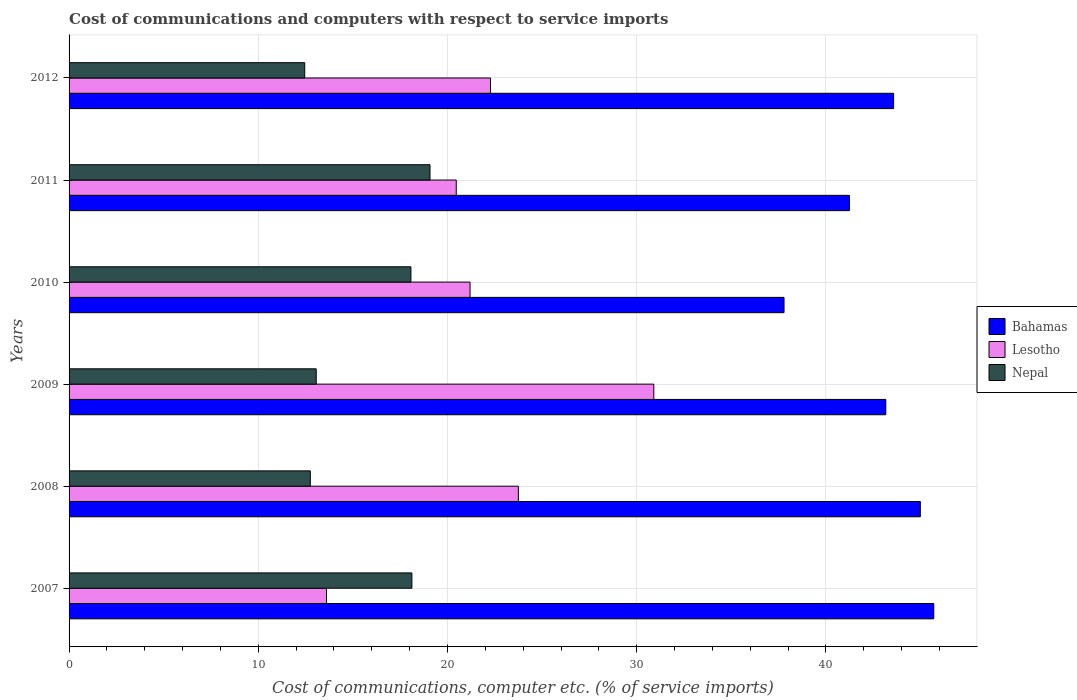How many different coloured bars are there?
Provide a short and direct response. 3. How many groups of bars are there?
Your answer should be very brief. 6. Are the number of bars on each tick of the Y-axis equal?
Your answer should be compact. Yes. How many bars are there on the 1st tick from the top?
Provide a short and direct response. 3. How many bars are there on the 4th tick from the bottom?
Offer a very short reply. 3. In how many cases, is the number of bars for a given year not equal to the number of legend labels?
Your response must be concise. 0. What is the cost of communications and computers in Nepal in 2010?
Your answer should be very brief. 18.07. Across all years, what is the maximum cost of communications and computers in Nepal?
Your answer should be very brief. 19.07. Across all years, what is the minimum cost of communications and computers in Nepal?
Provide a short and direct response. 12.45. In which year was the cost of communications and computers in Lesotho maximum?
Offer a very short reply. 2009. What is the total cost of communications and computers in Bahamas in the graph?
Provide a short and direct response. 256.45. What is the difference between the cost of communications and computers in Bahamas in 2009 and that in 2012?
Your answer should be compact. -0.41. What is the difference between the cost of communications and computers in Nepal in 2010 and the cost of communications and computers in Lesotho in 2009?
Offer a terse response. -12.84. What is the average cost of communications and computers in Bahamas per year?
Your answer should be very brief. 42.74. In the year 2010, what is the difference between the cost of communications and computers in Nepal and cost of communications and computers in Bahamas?
Your response must be concise. -19.72. In how many years, is the cost of communications and computers in Bahamas greater than 44 %?
Keep it short and to the point. 2. What is the ratio of the cost of communications and computers in Nepal in 2007 to that in 2012?
Make the answer very short. 1.45. Is the difference between the cost of communications and computers in Nepal in 2009 and 2012 greater than the difference between the cost of communications and computers in Bahamas in 2009 and 2012?
Provide a short and direct response. Yes. What is the difference between the highest and the second highest cost of communications and computers in Nepal?
Offer a terse response. 0.96. What is the difference between the highest and the lowest cost of communications and computers in Bahamas?
Your answer should be compact. 7.91. In how many years, is the cost of communications and computers in Nepal greater than the average cost of communications and computers in Nepal taken over all years?
Provide a succinct answer. 3. Is the sum of the cost of communications and computers in Nepal in 2008 and 2011 greater than the maximum cost of communications and computers in Bahamas across all years?
Offer a terse response. No. What does the 2nd bar from the top in 2008 represents?
Offer a terse response. Lesotho. What does the 2nd bar from the bottom in 2009 represents?
Keep it short and to the point. Lesotho. Is it the case that in every year, the sum of the cost of communications and computers in Bahamas and cost of communications and computers in Lesotho is greater than the cost of communications and computers in Nepal?
Offer a very short reply. Yes. How many bars are there?
Your response must be concise. 18. How many years are there in the graph?
Provide a succinct answer. 6. What is the difference between two consecutive major ticks on the X-axis?
Your answer should be compact. 10. Does the graph contain any zero values?
Keep it short and to the point. No. Where does the legend appear in the graph?
Keep it short and to the point. Center right. How many legend labels are there?
Offer a very short reply. 3. How are the legend labels stacked?
Provide a short and direct response. Vertical. What is the title of the graph?
Your answer should be compact. Cost of communications and computers with respect to service imports. What is the label or title of the X-axis?
Keep it short and to the point. Cost of communications, computer etc. (% of service imports). What is the label or title of the Y-axis?
Provide a short and direct response. Years. What is the Cost of communications, computer etc. (% of service imports) of Bahamas in 2007?
Offer a very short reply. 45.7. What is the Cost of communications, computer etc. (% of service imports) of Lesotho in 2007?
Offer a very short reply. 13.6. What is the Cost of communications, computer etc. (% of service imports) in Nepal in 2007?
Provide a succinct answer. 18.12. What is the Cost of communications, computer etc. (% of service imports) of Bahamas in 2008?
Provide a succinct answer. 44.99. What is the Cost of communications, computer etc. (% of service imports) of Lesotho in 2008?
Offer a very short reply. 23.74. What is the Cost of communications, computer etc. (% of service imports) of Nepal in 2008?
Provide a short and direct response. 12.75. What is the Cost of communications, computer etc. (% of service imports) in Bahamas in 2009?
Your response must be concise. 43.16. What is the Cost of communications, computer etc. (% of service imports) of Lesotho in 2009?
Ensure brevity in your answer.  30.9. What is the Cost of communications, computer etc. (% of service imports) in Nepal in 2009?
Provide a short and direct response. 13.06. What is the Cost of communications, computer etc. (% of service imports) in Bahamas in 2010?
Provide a succinct answer. 37.78. What is the Cost of communications, computer etc. (% of service imports) of Lesotho in 2010?
Provide a short and direct response. 21.19. What is the Cost of communications, computer etc. (% of service imports) in Nepal in 2010?
Provide a succinct answer. 18.07. What is the Cost of communications, computer etc. (% of service imports) of Bahamas in 2011?
Your answer should be very brief. 41.24. What is the Cost of communications, computer etc. (% of service imports) of Lesotho in 2011?
Give a very brief answer. 20.46. What is the Cost of communications, computer etc. (% of service imports) of Nepal in 2011?
Ensure brevity in your answer.  19.07. What is the Cost of communications, computer etc. (% of service imports) in Bahamas in 2012?
Your answer should be very brief. 43.57. What is the Cost of communications, computer etc. (% of service imports) of Lesotho in 2012?
Provide a short and direct response. 22.27. What is the Cost of communications, computer etc. (% of service imports) of Nepal in 2012?
Your response must be concise. 12.45. Across all years, what is the maximum Cost of communications, computer etc. (% of service imports) in Bahamas?
Provide a succinct answer. 45.7. Across all years, what is the maximum Cost of communications, computer etc. (% of service imports) in Lesotho?
Your answer should be compact. 30.9. Across all years, what is the maximum Cost of communications, computer etc. (% of service imports) in Nepal?
Keep it short and to the point. 19.07. Across all years, what is the minimum Cost of communications, computer etc. (% of service imports) in Bahamas?
Ensure brevity in your answer.  37.78. Across all years, what is the minimum Cost of communications, computer etc. (% of service imports) in Lesotho?
Provide a succinct answer. 13.6. Across all years, what is the minimum Cost of communications, computer etc. (% of service imports) in Nepal?
Keep it short and to the point. 12.45. What is the total Cost of communications, computer etc. (% of service imports) in Bahamas in the graph?
Make the answer very short. 256.45. What is the total Cost of communications, computer etc. (% of service imports) in Lesotho in the graph?
Provide a succinct answer. 132.17. What is the total Cost of communications, computer etc. (% of service imports) of Nepal in the graph?
Provide a short and direct response. 93.52. What is the difference between the Cost of communications, computer etc. (% of service imports) of Bahamas in 2007 and that in 2008?
Keep it short and to the point. 0.71. What is the difference between the Cost of communications, computer etc. (% of service imports) in Lesotho in 2007 and that in 2008?
Your answer should be compact. -10.14. What is the difference between the Cost of communications, computer etc. (% of service imports) in Nepal in 2007 and that in 2008?
Your response must be concise. 5.37. What is the difference between the Cost of communications, computer etc. (% of service imports) in Bahamas in 2007 and that in 2009?
Keep it short and to the point. 2.54. What is the difference between the Cost of communications, computer etc. (% of service imports) in Lesotho in 2007 and that in 2009?
Provide a short and direct response. -17.3. What is the difference between the Cost of communications, computer etc. (% of service imports) in Nepal in 2007 and that in 2009?
Keep it short and to the point. 5.05. What is the difference between the Cost of communications, computer etc. (% of service imports) of Bahamas in 2007 and that in 2010?
Offer a very short reply. 7.91. What is the difference between the Cost of communications, computer etc. (% of service imports) of Lesotho in 2007 and that in 2010?
Offer a very short reply. -7.59. What is the difference between the Cost of communications, computer etc. (% of service imports) of Nepal in 2007 and that in 2010?
Make the answer very short. 0.05. What is the difference between the Cost of communications, computer etc. (% of service imports) of Bahamas in 2007 and that in 2011?
Provide a succinct answer. 4.46. What is the difference between the Cost of communications, computer etc. (% of service imports) in Lesotho in 2007 and that in 2011?
Make the answer very short. -6.86. What is the difference between the Cost of communications, computer etc. (% of service imports) of Nepal in 2007 and that in 2011?
Make the answer very short. -0.96. What is the difference between the Cost of communications, computer etc. (% of service imports) of Bahamas in 2007 and that in 2012?
Make the answer very short. 2.12. What is the difference between the Cost of communications, computer etc. (% of service imports) of Lesotho in 2007 and that in 2012?
Give a very brief answer. -8.67. What is the difference between the Cost of communications, computer etc. (% of service imports) in Nepal in 2007 and that in 2012?
Make the answer very short. 5.66. What is the difference between the Cost of communications, computer etc. (% of service imports) of Bahamas in 2008 and that in 2009?
Give a very brief answer. 1.82. What is the difference between the Cost of communications, computer etc. (% of service imports) in Lesotho in 2008 and that in 2009?
Make the answer very short. -7.16. What is the difference between the Cost of communications, computer etc. (% of service imports) in Nepal in 2008 and that in 2009?
Make the answer very short. -0.31. What is the difference between the Cost of communications, computer etc. (% of service imports) of Bahamas in 2008 and that in 2010?
Give a very brief answer. 7.2. What is the difference between the Cost of communications, computer etc. (% of service imports) of Lesotho in 2008 and that in 2010?
Your answer should be very brief. 2.55. What is the difference between the Cost of communications, computer etc. (% of service imports) of Nepal in 2008 and that in 2010?
Your answer should be compact. -5.32. What is the difference between the Cost of communications, computer etc. (% of service imports) of Bahamas in 2008 and that in 2011?
Offer a terse response. 3.75. What is the difference between the Cost of communications, computer etc. (% of service imports) of Lesotho in 2008 and that in 2011?
Provide a succinct answer. 3.28. What is the difference between the Cost of communications, computer etc. (% of service imports) of Nepal in 2008 and that in 2011?
Ensure brevity in your answer.  -6.33. What is the difference between the Cost of communications, computer etc. (% of service imports) in Bahamas in 2008 and that in 2012?
Your response must be concise. 1.41. What is the difference between the Cost of communications, computer etc. (% of service imports) of Lesotho in 2008 and that in 2012?
Your answer should be very brief. 1.47. What is the difference between the Cost of communications, computer etc. (% of service imports) of Nepal in 2008 and that in 2012?
Your response must be concise. 0.3. What is the difference between the Cost of communications, computer etc. (% of service imports) of Bahamas in 2009 and that in 2010?
Ensure brevity in your answer.  5.38. What is the difference between the Cost of communications, computer etc. (% of service imports) of Lesotho in 2009 and that in 2010?
Your answer should be compact. 9.71. What is the difference between the Cost of communications, computer etc. (% of service imports) of Nepal in 2009 and that in 2010?
Provide a succinct answer. -5. What is the difference between the Cost of communications, computer etc. (% of service imports) of Bahamas in 2009 and that in 2011?
Offer a very short reply. 1.92. What is the difference between the Cost of communications, computer etc. (% of service imports) of Lesotho in 2009 and that in 2011?
Your answer should be compact. 10.44. What is the difference between the Cost of communications, computer etc. (% of service imports) in Nepal in 2009 and that in 2011?
Keep it short and to the point. -6.01. What is the difference between the Cost of communications, computer etc. (% of service imports) in Bahamas in 2009 and that in 2012?
Make the answer very short. -0.41. What is the difference between the Cost of communications, computer etc. (% of service imports) of Lesotho in 2009 and that in 2012?
Keep it short and to the point. 8.63. What is the difference between the Cost of communications, computer etc. (% of service imports) of Nepal in 2009 and that in 2012?
Ensure brevity in your answer.  0.61. What is the difference between the Cost of communications, computer etc. (% of service imports) in Bahamas in 2010 and that in 2011?
Offer a terse response. -3.46. What is the difference between the Cost of communications, computer etc. (% of service imports) of Lesotho in 2010 and that in 2011?
Provide a short and direct response. 0.73. What is the difference between the Cost of communications, computer etc. (% of service imports) of Nepal in 2010 and that in 2011?
Your answer should be compact. -1.01. What is the difference between the Cost of communications, computer etc. (% of service imports) in Bahamas in 2010 and that in 2012?
Your response must be concise. -5.79. What is the difference between the Cost of communications, computer etc. (% of service imports) in Lesotho in 2010 and that in 2012?
Your response must be concise. -1.08. What is the difference between the Cost of communications, computer etc. (% of service imports) in Nepal in 2010 and that in 2012?
Your response must be concise. 5.61. What is the difference between the Cost of communications, computer etc. (% of service imports) of Bahamas in 2011 and that in 2012?
Give a very brief answer. -2.33. What is the difference between the Cost of communications, computer etc. (% of service imports) in Lesotho in 2011 and that in 2012?
Make the answer very short. -1.81. What is the difference between the Cost of communications, computer etc. (% of service imports) in Nepal in 2011 and that in 2012?
Ensure brevity in your answer.  6.62. What is the difference between the Cost of communications, computer etc. (% of service imports) in Bahamas in 2007 and the Cost of communications, computer etc. (% of service imports) in Lesotho in 2008?
Your response must be concise. 21.95. What is the difference between the Cost of communications, computer etc. (% of service imports) in Bahamas in 2007 and the Cost of communications, computer etc. (% of service imports) in Nepal in 2008?
Your answer should be compact. 32.95. What is the difference between the Cost of communications, computer etc. (% of service imports) of Lesotho in 2007 and the Cost of communications, computer etc. (% of service imports) of Nepal in 2008?
Provide a succinct answer. 0.86. What is the difference between the Cost of communications, computer etc. (% of service imports) of Bahamas in 2007 and the Cost of communications, computer etc. (% of service imports) of Lesotho in 2009?
Provide a succinct answer. 14.8. What is the difference between the Cost of communications, computer etc. (% of service imports) in Bahamas in 2007 and the Cost of communications, computer etc. (% of service imports) in Nepal in 2009?
Provide a short and direct response. 32.64. What is the difference between the Cost of communications, computer etc. (% of service imports) of Lesotho in 2007 and the Cost of communications, computer etc. (% of service imports) of Nepal in 2009?
Make the answer very short. 0.54. What is the difference between the Cost of communications, computer etc. (% of service imports) of Bahamas in 2007 and the Cost of communications, computer etc. (% of service imports) of Lesotho in 2010?
Your response must be concise. 24.51. What is the difference between the Cost of communications, computer etc. (% of service imports) of Bahamas in 2007 and the Cost of communications, computer etc. (% of service imports) of Nepal in 2010?
Offer a very short reply. 27.63. What is the difference between the Cost of communications, computer etc. (% of service imports) of Lesotho in 2007 and the Cost of communications, computer etc. (% of service imports) of Nepal in 2010?
Provide a short and direct response. -4.46. What is the difference between the Cost of communications, computer etc. (% of service imports) in Bahamas in 2007 and the Cost of communications, computer etc. (% of service imports) in Lesotho in 2011?
Your answer should be very brief. 25.24. What is the difference between the Cost of communications, computer etc. (% of service imports) in Bahamas in 2007 and the Cost of communications, computer etc. (% of service imports) in Nepal in 2011?
Give a very brief answer. 26.62. What is the difference between the Cost of communications, computer etc. (% of service imports) of Lesotho in 2007 and the Cost of communications, computer etc. (% of service imports) of Nepal in 2011?
Provide a short and direct response. -5.47. What is the difference between the Cost of communications, computer etc. (% of service imports) of Bahamas in 2007 and the Cost of communications, computer etc. (% of service imports) of Lesotho in 2012?
Your answer should be very brief. 23.43. What is the difference between the Cost of communications, computer etc. (% of service imports) in Bahamas in 2007 and the Cost of communications, computer etc. (% of service imports) in Nepal in 2012?
Your answer should be compact. 33.24. What is the difference between the Cost of communications, computer etc. (% of service imports) in Lesotho in 2007 and the Cost of communications, computer etc. (% of service imports) in Nepal in 2012?
Keep it short and to the point. 1.15. What is the difference between the Cost of communications, computer etc. (% of service imports) of Bahamas in 2008 and the Cost of communications, computer etc. (% of service imports) of Lesotho in 2009?
Your answer should be very brief. 14.09. What is the difference between the Cost of communications, computer etc. (% of service imports) of Bahamas in 2008 and the Cost of communications, computer etc. (% of service imports) of Nepal in 2009?
Provide a succinct answer. 31.93. What is the difference between the Cost of communications, computer etc. (% of service imports) of Lesotho in 2008 and the Cost of communications, computer etc. (% of service imports) of Nepal in 2009?
Your response must be concise. 10.68. What is the difference between the Cost of communications, computer etc. (% of service imports) of Bahamas in 2008 and the Cost of communications, computer etc. (% of service imports) of Lesotho in 2010?
Keep it short and to the point. 23.8. What is the difference between the Cost of communications, computer etc. (% of service imports) of Bahamas in 2008 and the Cost of communications, computer etc. (% of service imports) of Nepal in 2010?
Your response must be concise. 26.92. What is the difference between the Cost of communications, computer etc. (% of service imports) in Lesotho in 2008 and the Cost of communications, computer etc. (% of service imports) in Nepal in 2010?
Give a very brief answer. 5.68. What is the difference between the Cost of communications, computer etc. (% of service imports) of Bahamas in 2008 and the Cost of communications, computer etc. (% of service imports) of Lesotho in 2011?
Your answer should be compact. 24.53. What is the difference between the Cost of communications, computer etc. (% of service imports) of Bahamas in 2008 and the Cost of communications, computer etc. (% of service imports) of Nepal in 2011?
Give a very brief answer. 25.91. What is the difference between the Cost of communications, computer etc. (% of service imports) in Lesotho in 2008 and the Cost of communications, computer etc. (% of service imports) in Nepal in 2011?
Keep it short and to the point. 4.67. What is the difference between the Cost of communications, computer etc. (% of service imports) in Bahamas in 2008 and the Cost of communications, computer etc. (% of service imports) in Lesotho in 2012?
Offer a very short reply. 22.72. What is the difference between the Cost of communications, computer etc. (% of service imports) in Bahamas in 2008 and the Cost of communications, computer etc. (% of service imports) in Nepal in 2012?
Your answer should be very brief. 32.53. What is the difference between the Cost of communications, computer etc. (% of service imports) of Lesotho in 2008 and the Cost of communications, computer etc. (% of service imports) of Nepal in 2012?
Ensure brevity in your answer.  11.29. What is the difference between the Cost of communications, computer etc. (% of service imports) of Bahamas in 2009 and the Cost of communications, computer etc. (% of service imports) of Lesotho in 2010?
Ensure brevity in your answer.  21.97. What is the difference between the Cost of communications, computer etc. (% of service imports) in Bahamas in 2009 and the Cost of communications, computer etc. (% of service imports) in Nepal in 2010?
Provide a succinct answer. 25.1. What is the difference between the Cost of communications, computer etc. (% of service imports) in Lesotho in 2009 and the Cost of communications, computer etc. (% of service imports) in Nepal in 2010?
Give a very brief answer. 12.84. What is the difference between the Cost of communications, computer etc. (% of service imports) in Bahamas in 2009 and the Cost of communications, computer etc. (% of service imports) in Lesotho in 2011?
Provide a short and direct response. 22.7. What is the difference between the Cost of communications, computer etc. (% of service imports) in Bahamas in 2009 and the Cost of communications, computer etc. (% of service imports) in Nepal in 2011?
Your answer should be compact. 24.09. What is the difference between the Cost of communications, computer etc. (% of service imports) of Lesotho in 2009 and the Cost of communications, computer etc. (% of service imports) of Nepal in 2011?
Your response must be concise. 11.83. What is the difference between the Cost of communications, computer etc. (% of service imports) in Bahamas in 2009 and the Cost of communications, computer etc. (% of service imports) in Lesotho in 2012?
Provide a short and direct response. 20.89. What is the difference between the Cost of communications, computer etc. (% of service imports) in Bahamas in 2009 and the Cost of communications, computer etc. (% of service imports) in Nepal in 2012?
Your answer should be compact. 30.71. What is the difference between the Cost of communications, computer etc. (% of service imports) of Lesotho in 2009 and the Cost of communications, computer etc. (% of service imports) of Nepal in 2012?
Keep it short and to the point. 18.45. What is the difference between the Cost of communications, computer etc. (% of service imports) of Bahamas in 2010 and the Cost of communications, computer etc. (% of service imports) of Lesotho in 2011?
Provide a succinct answer. 17.32. What is the difference between the Cost of communications, computer etc. (% of service imports) of Bahamas in 2010 and the Cost of communications, computer etc. (% of service imports) of Nepal in 2011?
Provide a succinct answer. 18.71. What is the difference between the Cost of communications, computer etc. (% of service imports) in Lesotho in 2010 and the Cost of communications, computer etc. (% of service imports) in Nepal in 2011?
Keep it short and to the point. 2.12. What is the difference between the Cost of communications, computer etc. (% of service imports) of Bahamas in 2010 and the Cost of communications, computer etc. (% of service imports) of Lesotho in 2012?
Ensure brevity in your answer.  15.51. What is the difference between the Cost of communications, computer etc. (% of service imports) of Bahamas in 2010 and the Cost of communications, computer etc. (% of service imports) of Nepal in 2012?
Provide a succinct answer. 25.33. What is the difference between the Cost of communications, computer etc. (% of service imports) in Lesotho in 2010 and the Cost of communications, computer etc. (% of service imports) in Nepal in 2012?
Your answer should be very brief. 8.74. What is the difference between the Cost of communications, computer etc. (% of service imports) in Bahamas in 2011 and the Cost of communications, computer etc. (% of service imports) in Lesotho in 2012?
Make the answer very short. 18.97. What is the difference between the Cost of communications, computer etc. (% of service imports) of Bahamas in 2011 and the Cost of communications, computer etc. (% of service imports) of Nepal in 2012?
Keep it short and to the point. 28.79. What is the difference between the Cost of communications, computer etc. (% of service imports) of Lesotho in 2011 and the Cost of communications, computer etc. (% of service imports) of Nepal in 2012?
Make the answer very short. 8.01. What is the average Cost of communications, computer etc. (% of service imports) of Bahamas per year?
Give a very brief answer. 42.74. What is the average Cost of communications, computer etc. (% of service imports) in Lesotho per year?
Provide a short and direct response. 22.03. What is the average Cost of communications, computer etc. (% of service imports) of Nepal per year?
Make the answer very short. 15.59. In the year 2007, what is the difference between the Cost of communications, computer etc. (% of service imports) in Bahamas and Cost of communications, computer etc. (% of service imports) in Lesotho?
Your answer should be very brief. 32.09. In the year 2007, what is the difference between the Cost of communications, computer etc. (% of service imports) in Bahamas and Cost of communications, computer etc. (% of service imports) in Nepal?
Offer a very short reply. 27.58. In the year 2007, what is the difference between the Cost of communications, computer etc. (% of service imports) in Lesotho and Cost of communications, computer etc. (% of service imports) in Nepal?
Your response must be concise. -4.51. In the year 2008, what is the difference between the Cost of communications, computer etc. (% of service imports) of Bahamas and Cost of communications, computer etc. (% of service imports) of Lesotho?
Your answer should be compact. 21.24. In the year 2008, what is the difference between the Cost of communications, computer etc. (% of service imports) in Bahamas and Cost of communications, computer etc. (% of service imports) in Nepal?
Offer a terse response. 32.24. In the year 2008, what is the difference between the Cost of communications, computer etc. (% of service imports) in Lesotho and Cost of communications, computer etc. (% of service imports) in Nepal?
Keep it short and to the point. 11. In the year 2009, what is the difference between the Cost of communications, computer etc. (% of service imports) of Bahamas and Cost of communications, computer etc. (% of service imports) of Lesotho?
Provide a succinct answer. 12.26. In the year 2009, what is the difference between the Cost of communications, computer etc. (% of service imports) of Bahamas and Cost of communications, computer etc. (% of service imports) of Nepal?
Provide a short and direct response. 30.1. In the year 2009, what is the difference between the Cost of communications, computer etc. (% of service imports) of Lesotho and Cost of communications, computer etc. (% of service imports) of Nepal?
Give a very brief answer. 17.84. In the year 2010, what is the difference between the Cost of communications, computer etc. (% of service imports) of Bahamas and Cost of communications, computer etc. (% of service imports) of Lesotho?
Make the answer very short. 16.59. In the year 2010, what is the difference between the Cost of communications, computer etc. (% of service imports) of Bahamas and Cost of communications, computer etc. (% of service imports) of Nepal?
Ensure brevity in your answer.  19.72. In the year 2010, what is the difference between the Cost of communications, computer etc. (% of service imports) in Lesotho and Cost of communications, computer etc. (% of service imports) in Nepal?
Provide a short and direct response. 3.12. In the year 2011, what is the difference between the Cost of communications, computer etc. (% of service imports) in Bahamas and Cost of communications, computer etc. (% of service imports) in Lesotho?
Provide a succinct answer. 20.78. In the year 2011, what is the difference between the Cost of communications, computer etc. (% of service imports) of Bahamas and Cost of communications, computer etc. (% of service imports) of Nepal?
Keep it short and to the point. 22.17. In the year 2011, what is the difference between the Cost of communications, computer etc. (% of service imports) in Lesotho and Cost of communications, computer etc. (% of service imports) in Nepal?
Your response must be concise. 1.39. In the year 2012, what is the difference between the Cost of communications, computer etc. (% of service imports) of Bahamas and Cost of communications, computer etc. (% of service imports) of Lesotho?
Provide a short and direct response. 21.3. In the year 2012, what is the difference between the Cost of communications, computer etc. (% of service imports) in Bahamas and Cost of communications, computer etc. (% of service imports) in Nepal?
Offer a terse response. 31.12. In the year 2012, what is the difference between the Cost of communications, computer etc. (% of service imports) in Lesotho and Cost of communications, computer etc. (% of service imports) in Nepal?
Your answer should be compact. 9.82. What is the ratio of the Cost of communications, computer etc. (% of service imports) in Bahamas in 2007 to that in 2008?
Give a very brief answer. 1.02. What is the ratio of the Cost of communications, computer etc. (% of service imports) of Lesotho in 2007 to that in 2008?
Your response must be concise. 0.57. What is the ratio of the Cost of communications, computer etc. (% of service imports) in Nepal in 2007 to that in 2008?
Provide a succinct answer. 1.42. What is the ratio of the Cost of communications, computer etc. (% of service imports) of Bahamas in 2007 to that in 2009?
Ensure brevity in your answer.  1.06. What is the ratio of the Cost of communications, computer etc. (% of service imports) in Lesotho in 2007 to that in 2009?
Your answer should be very brief. 0.44. What is the ratio of the Cost of communications, computer etc. (% of service imports) in Nepal in 2007 to that in 2009?
Your answer should be very brief. 1.39. What is the ratio of the Cost of communications, computer etc. (% of service imports) in Bahamas in 2007 to that in 2010?
Keep it short and to the point. 1.21. What is the ratio of the Cost of communications, computer etc. (% of service imports) of Lesotho in 2007 to that in 2010?
Your answer should be compact. 0.64. What is the ratio of the Cost of communications, computer etc. (% of service imports) of Bahamas in 2007 to that in 2011?
Offer a very short reply. 1.11. What is the ratio of the Cost of communications, computer etc. (% of service imports) of Lesotho in 2007 to that in 2011?
Offer a terse response. 0.66. What is the ratio of the Cost of communications, computer etc. (% of service imports) in Nepal in 2007 to that in 2011?
Your answer should be compact. 0.95. What is the ratio of the Cost of communications, computer etc. (% of service imports) in Bahamas in 2007 to that in 2012?
Offer a very short reply. 1.05. What is the ratio of the Cost of communications, computer etc. (% of service imports) in Lesotho in 2007 to that in 2012?
Provide a short and direct response. 0.61. What is the ratio of the Cost of communications, computer etc. (% of service imports) in Nepal in 2007 to that in 2012?
Your answer should be compact. 1.45. What is the ratio of the Cost of communications, computer etc. (% of service imports) of Bahamas in 2008 to that in 2009?
Provide a succinct answer. 1.04. What is the ratio of the Cost of communications, computer etc. (% of service imports) of Lesotho in 2008 to that in 2009?
Make the answer very short. 0.77. What is the ratio of the Cost of communications, computer etc. (% of service imports) in Nepal in 2008 to that in 2009?
Provide a succinct answer. 0.98. What is the ratio of the Cost of communications, computer etc. (% of service imports) of Bahamas in 2008 to that in 2010?
Provide a short and direct response. 1.19. What is the ratio of the Cost of communications, computer etc. (% of service imports) of Lesotho in 2008 to that in 2010?
Keep it short and to the point. 1.12. What is the ratio of the Cost of communications, computer etc. (% of service imports) in Nepal in 2008 to that in 2010?
Make the answer very short. 0.71. What is the ratio of the Cost of communications, computer etc. (% of service imports) of Lesotho in 2008 to that in 2011?
Your response must be concise. 1.16. What is the ratio of the Cost of communications, computer etc. (% of service imports) in Nepal in 2008 to that in 2011?
Ensure brevity in your answer.  0.67. What is the ratio of the Cost of communications, computer etc. (% of service imports) in Bahamas in 2008 to that in 2012?
Make the answer very short. 1.03. What is the ratio of the Cost of communications, computer etc. (% of service imports) of Lesotho in 2008 to that in 2012?
Provide a succinct answer. 1.07. What is the ratio of the Cost of communications, computer etc. (% of service imports) in Nepal in 2008 to that in 2012?
Give a very brief answer. 1.02. What is the ratio of the Cost of communications, computer etc. (% of service imports) of Bahamas in 2009 to that in 2010?
Ensure brevity in your answer.  1.14. What is the ratio of the Cost of communications, computer etc. (% of service imports) of Lesotho in 2009 to that in 2010?
Provide a short and direct response. 1.46. What is the ratio of the Cost of communications, computer etc. (% of service imports) of Nepal in 2009 to that in 2010?
Offer a terse response. 0.72. What is the ratio of the Cost of communications, computer etc. (% of service imports) of Bahamas in 2009 to that in 2011?
Make the answer very short. 1.05. What is the ratio of the Cost of communications, computer etc. (% of service imports) in Lesotho in 2009 to that in 2011?
Keep it short and to the point. 1.51. What is the ratio of the Cost of communications, computer etc. (% of service imports) in Nepal in 2009 to that in 2011?
Make the answer very short. 0.68. What is the ratio of the Cost of communications, computer etc. (% of service imports) of Bahamas in 2009 to that in 2012?
Give a very brief answer. 0.99. What is the ratio of the Cost of communications, computer etc. (% of service imports) of Lesotho in 2009 to that in 2012?
Provide a short and direct response. 1.39. What is the ratio of the Cost of communications, computer etc. (% of service imports) in Nepal in 2009 to that in 2012?
Give a very brief answer. 1.05. What is the ratio of the Cost of communications, computer etc. (% of service imports) of Bahamas in 2010 to that in 2011?
Keep it short and to the point. 0.92. What is the ratio of the Cost of communications, computer etc. (% of service imports) in Lesotho in 2010 to that in 2011?
Provide a succinct answer. 1.04. What is the ratio of the Cost of communications, computer etc. (% of service imports) in Nepal in 2010 to that in 2011?
Your answer should be compact. 0.95. What is the ratio of the Cost of communications, computer etc. (% of service imports) in Bahamas in 2010 to that in 2012?
Give a very brief answer. 0.87. What is the ratio of the Cost of communications, computer etc. (% of service imports) of Lesotho in 2010 to that in 2012?
Your response must be concise. 0.95. What is the ratio of the Cost of communications, computer etc. (% of service imports) of Nepal in 2010 to that in 2012?
Provide a short and direct response. 1.45. What is the ratio of the Cost of communications, computer etc. (% of service imports) of Bahamas in 2011 to that in 2012?
Make the answer very short. 0.95. What is the ratio of the Cost of communications, computer etc. (% of service imports) in Lesotho in 2011 to that in 2012?
Provide a short and direct response. 0.92. What is the ratio of the Cost of communications, computer etc. (% of service imports) of Nepal in 2011 to that in 2012?
Offer a very short reply. 1.53. What is the difference between the highest and the second highest Cost of communications, computer etc. (% of service imports) of Bahamas?
Give a very brief answer. 0.71. What is the difference between the highest and the second highest Cost of communications, computer etc. (% of service imports) of Lesotho?
Your answer should be compact. 7.16. What is the difference between the highest and the second highest Cost of communications, computer etc. (% of service imports) of Nepal?
Your response must be concise. 0.96. What is the difference between the highest and the lowest Cost of communications, computer etc. (% of service imports) in Bahamas?
Make the answer very short. 7.91. What is the difference between the highest and the lowest Cost of communications, computer etc. (% of service imports) in Lesotho?
Offer a very short reply. 17.3. What is the difference between the highest and the lowest Cost of communications, computer etc. (% of service imports) in Nepal?
Give a very brief answer. 6.62. 